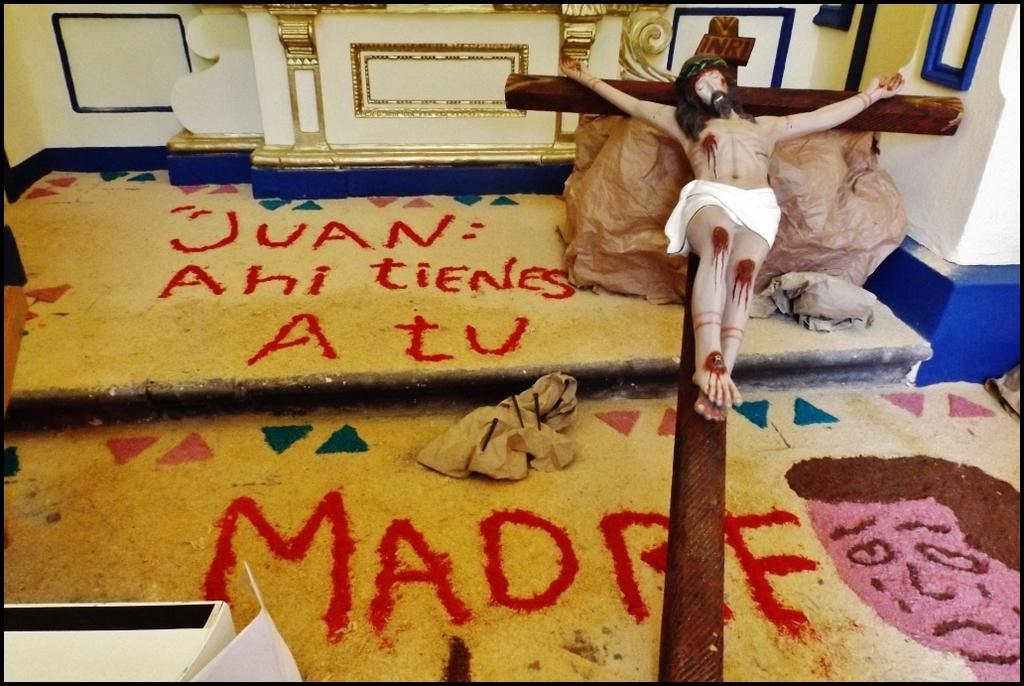What is the main subject of the image? There is a depiction of Christ on the cross in the image. What else can be seen on the floor in the image? There is a painting on the floor in the image. What is visible in the background of the image? There is a wall visible in the background of the image. Where was the image taken? The image was taken in a hall. What type of milk is being poured on the snakes in the image? There are no snakes or milk present in the image; it features a depiction of Christ on the cross and a painting on the floor. Is there a sofa visible in the image? No, there is no sofa present in the image. 